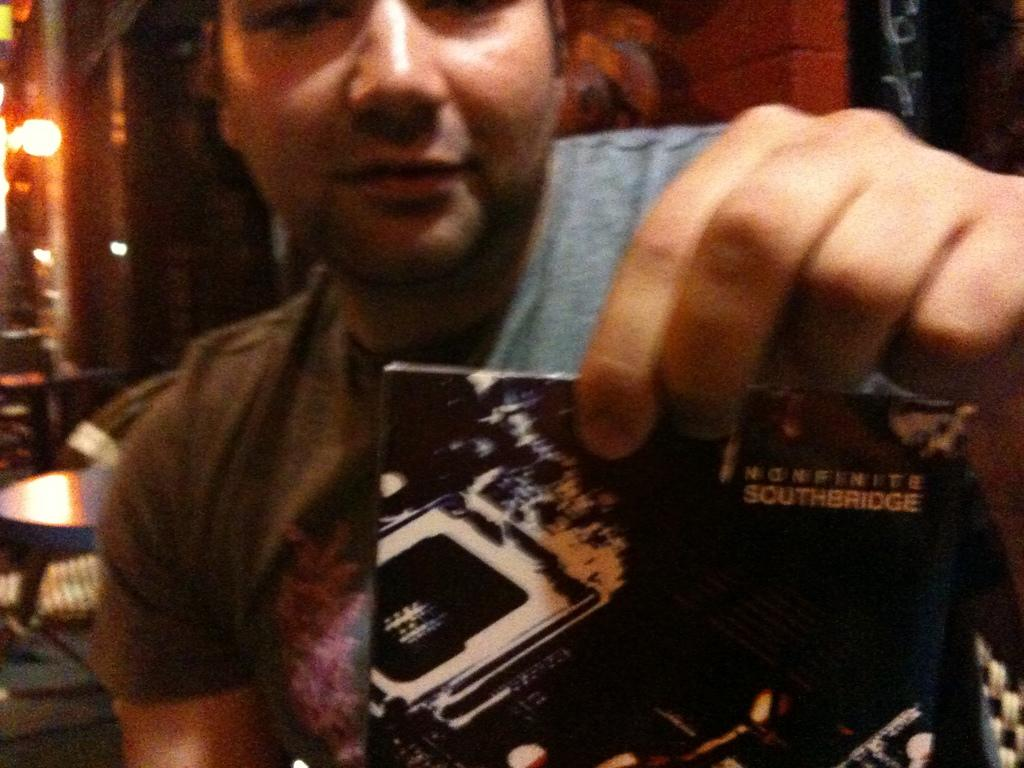What is the person in the image doing? The person is sitting in the image. What is the person holding in the image? The person is holding a paper. What can be seen in the background of the image? There is a table and a wall in the background of the image. What is attached to the wall in the background of the image? There is a light on the wall in the background of the image. How many beans are on the table in the image? There is no mention of beans in the image, so we cannot determine their presence or quantity. 